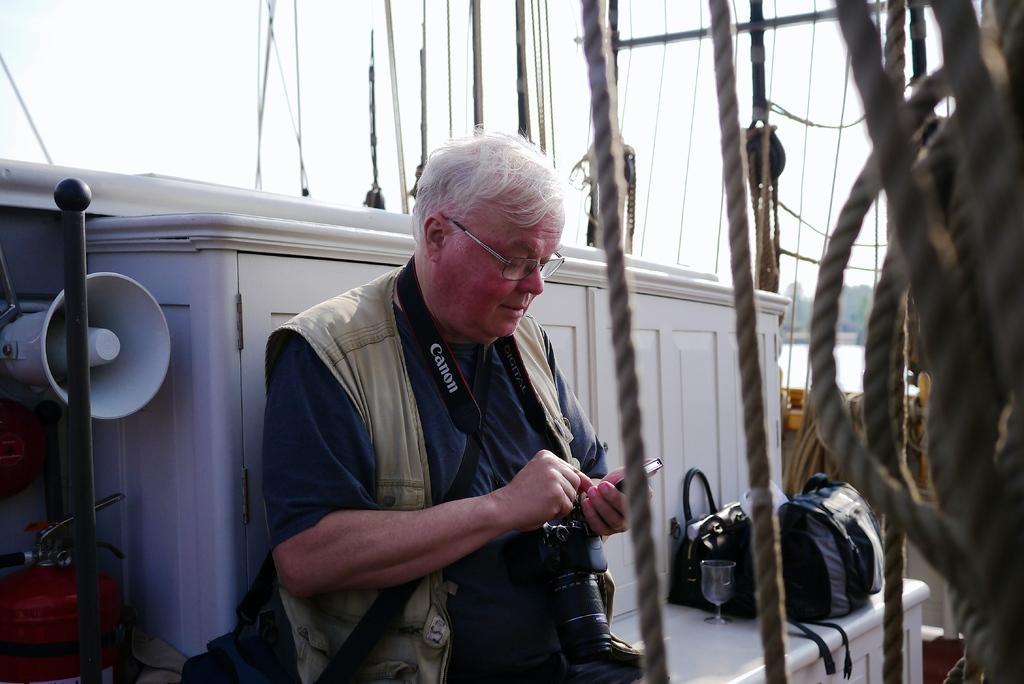Please provide a concise description of this image. In this image there is a person wearing a camera is holding a mobile phone and is looking into it, behind the person there is a metal rod, a speaker, a fire extinguisher and there are a few bags and a glass placed on the wood surface, in the background of the image there are trees and water. 